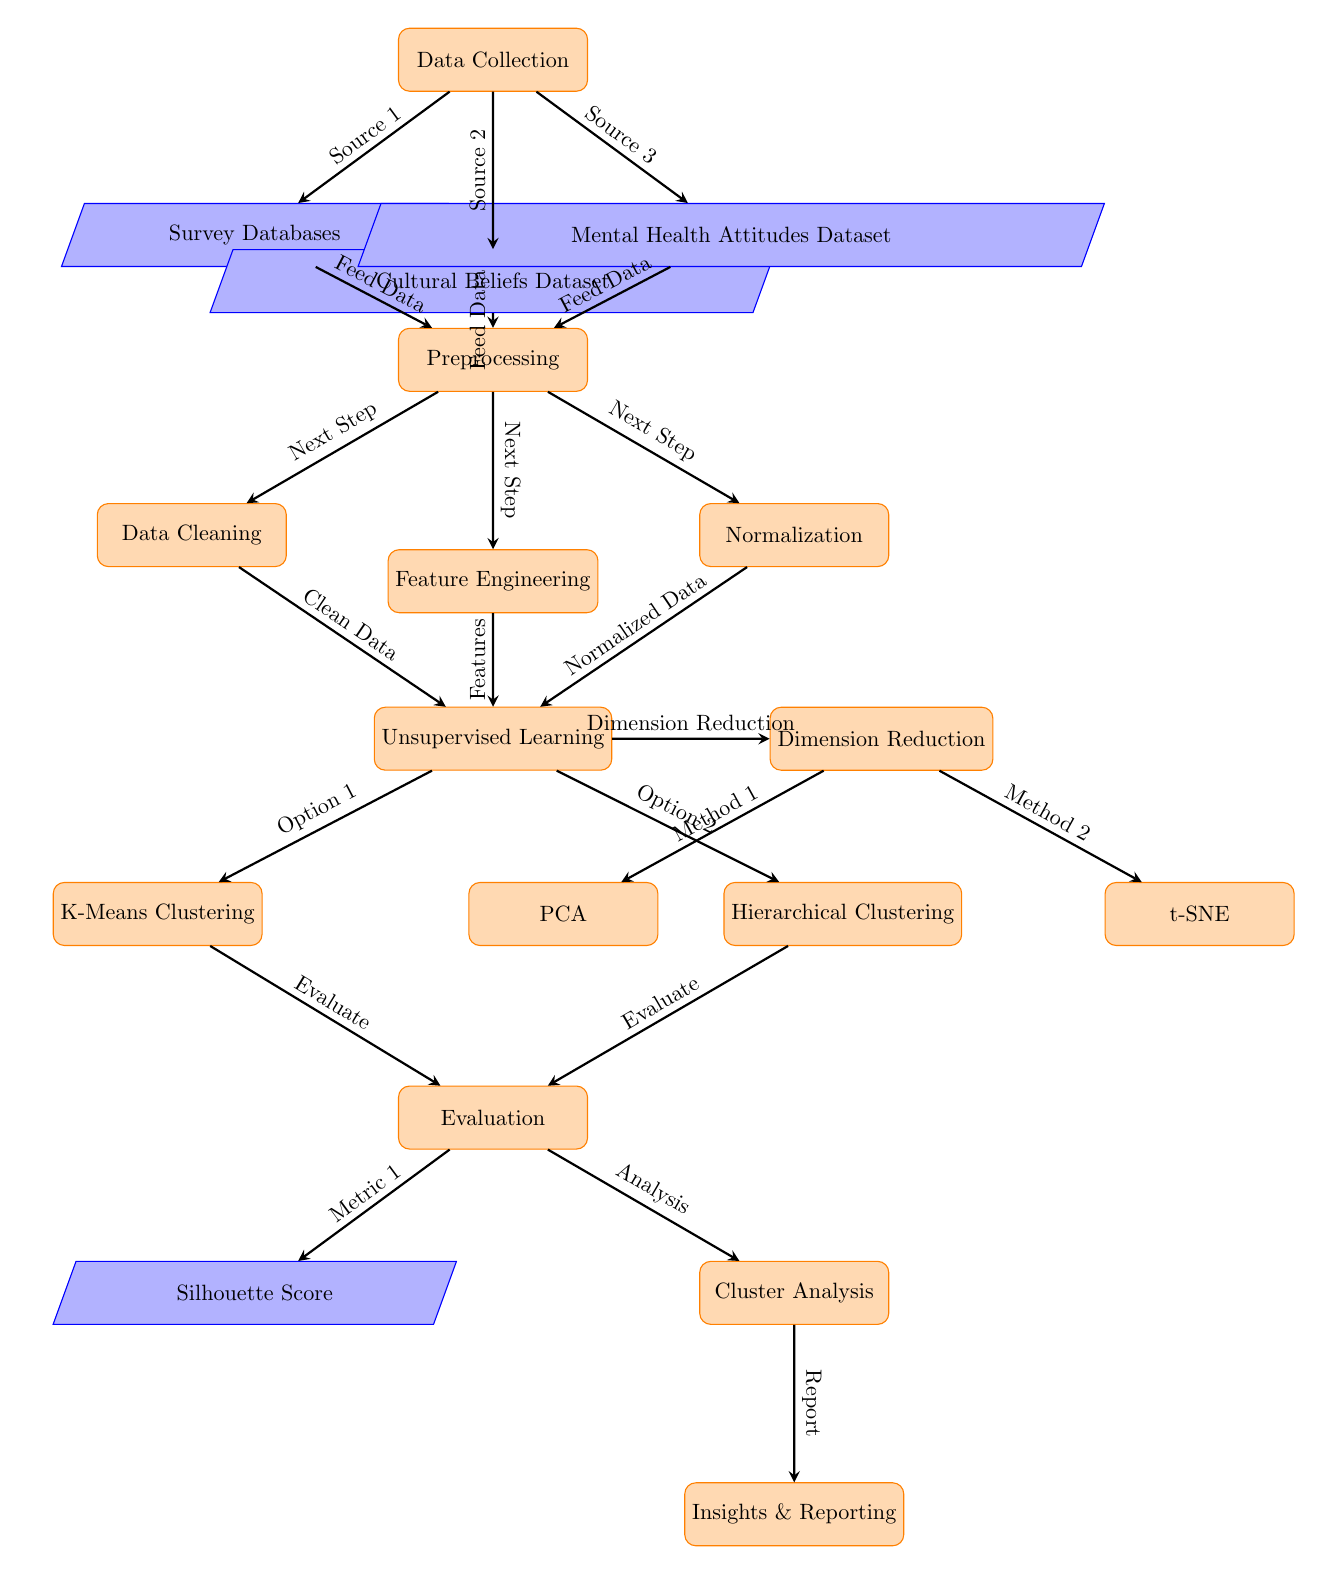What are the three sources of data in the data collection phase? The sources of data in the data collection phase are indicated as Survey Databases, Cultural Beliefs Dataset, and Mental Health Attitudes Dataset. These nodes are connected to the Data Collection node, showing the inputs needed for analysis.
Answer: Survey Databases, Cultural Beliefs Dataset, Mental Health Attitudes Dataset How many processes are involved in the preprocessing stage? In the preprocessing stage, there are three processes: Data Cleaning, Feature Engineering, and Normalization. Each of these nodes is connected to a central Preprocessing node, indicating they are part of this stage.
Answer: Three What methods are used for dimension reduction? The methods for dimension reduction are PCA and t-SNE, which can be seen as the two nodes that branch out from the Dimension Reduction node. This shows that these are the chosen techniques for reducing dimensionality in the analysis.
Answer: PCA, t-SNE Which clustering method evaluates to the silhouette score? The K-Means Clustering method evaluates to the Silhouette Score, which is indicated by the arrow leading from the K-Means Clustering node directly to the Evaluation node, where the Silhouette Score is assessed as a metric.
Answer: K-Means Clustering What are the two types of clustering employed in the unsupervised learning phase? The two types of clustering in the unsupervised learning phase are K-Means Clustering and Hierarchical Clustering, both of which are visually positioned below the Unsupervised Learning node, indicating they are the techniques applied in this phase.
Answer: K-Means Clustering, Hierarchical Clustering How is the output of the cluster analysis utilized after evaluation? The output of the cluster analysis is reported as insights, which is indicated by an arrow from the Cluster Analysis node pointing to the Insights & Reporting node, showing that the findings are documented and communicated in this final stage.
Answer: Insights & Reporting Which node is responsible for cleaning data before clustering? The Data Cleaning node is responsible for cleaning data before clustering, as indicated by an arrow leading from the Data Cleaning node to the Unsupervised Learning node, demonstrating the flow of data preparation before applying clustering algorithms.
Answer: Data Cleaning Which process is conducted immediately after data collection? The process conducted immediately after data collection is Preprocessing, as indicated by the direct connection from the Data Collection node to the Preprocessing node in the diagram.
Answer: Preprocessing What is the main goal of unsupervised learning in this context? The main goal of unsupervised learning in this context is to identify patterns or structures within the cultural attitudes towards mental health from the datasets, which is implied by the title of the Unsupervised Learning node itself.
Answer: Identify patterns 